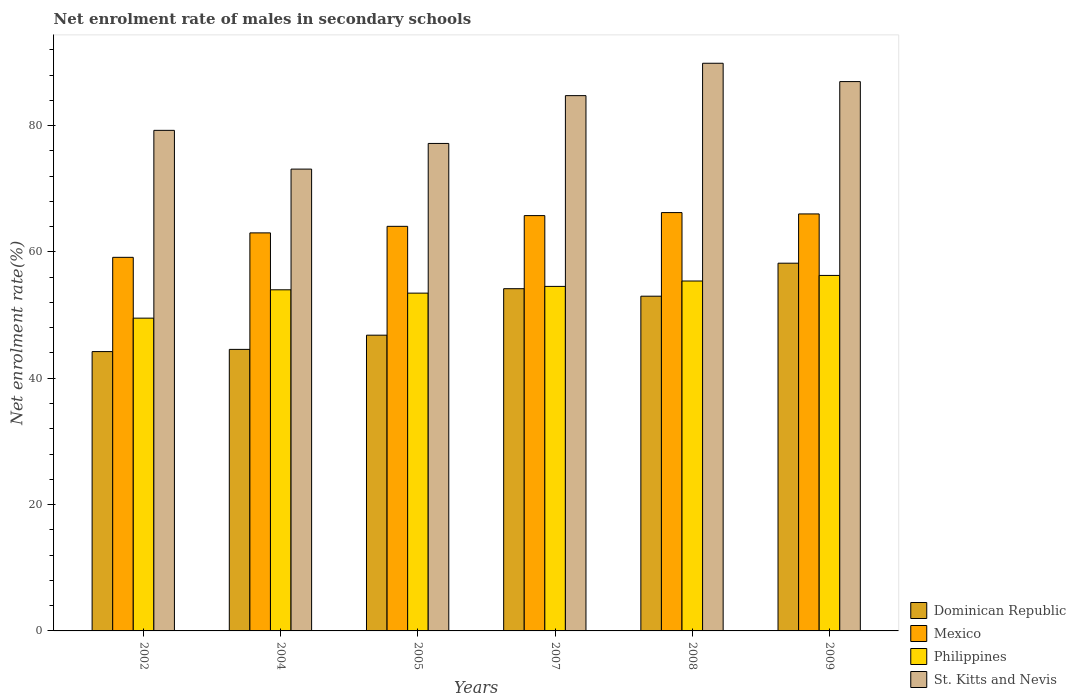How many bars are there on the 2nd tick from the left?
Your answer should be very brief. 4. How many bars are there on the 5th tick from the right?
Ensure brevity in your answer.  4. What is the net enrolment rate of males in secondary schools in St. Kitts and Nevis in 2008?
Your response must be concise. 89.87. Across all years, what is the maximum net enrolment rate of males in secondary schools in St. Kitts and Nevis?
Provide a short and direct response. 89.87. Across all years, what is the minimum net enrolment rate of males in secondary schools in Dominican Republic?
Provide a short and direct response. 44.22. In which year was the net enrolment rate of males in secondary schools in Dominican Republic minimum?
Keep it short and to the point. 2002. What is the total net enrolment rate of males in secondary schools in St. Kitts and Nevis in the graph?
Provide a short and direct response. 491.13. What is the difference between the net enrolment rate of males in secondary schools in Dominican Republic in 2004 and that in 2008?
Provide a short and direct response. -8.42. What is the difference between the net enrolment rate of males in secondary schools in St. Kitts and Nevis in 2008 and the net enrolment rate of males in secondary schools in Mexico in 2005?
Offer a very short reply. 25.82. What is the average net enrolment rate of males in secondary schools in St. Kitts and Nevis per year?
Provide a succinct answer. 81.85. In the year 2005, what is the difference between the net enrolment rate of males in secondary schools in Philippines and net enrolment rate of males in secondary schools in Dominican Republic?
Make the answer very short. 6.66. What is the ratio of the net enrolment rate of males in secondary schools in Dominican Republic in 2005 to that in 2008?
Provide a short and direct response. 0.88. What is the difference between the highest and the second highest net enrolment rate of males in secondary schools in Dominican Republic?
Ensure brevity in your answer.  4.04. What is the difference between the highest and the lowest net enrolment rate of males in secondary schools in Mexico?
Your response must be concise. 7.08. In how many years, is the net enrolment rate of males in secondary schools in Philippines greater than the average net enrolment rate of males in secondary schools in Philippines taken over all years?
Your answer should be very brief. 4. Is the sum of the net enrolment rate of males in secondary schools in Philippines in 2008 and 2009 greater than the maximum net enrolment rate of males in secondary schools in Dominican Republic across all years?
Your answer should be very brief. Yes. Is it the case that in every year, the sum of the net enrolment rate of males in secondary schools in St. Kitts and Nevis and net enrolment rate of males in secondary schools in Mexico is greater than the net enrolment rate of males in secondary schools in Philippines?
Provide a short and direct response. Yes. How many years are there in the graph?
Provide a succinct answer. 6. What is the difference between two consecutive major ticks on the Y-axis?
Ensure brevity in your answer.  20. Are the values on the major ticks of Y-axis written in scientific E-notation?
Offer a very short reply. No. Does the graph contain any zero values?
Give a very brief answer. No. Does the graph contain grids?
Give a very brief answer. No. How many legend labels are there?
Offer a very short reply. 4. What is the title of the graph?
Provide a short and direct response. Net enrolment rate of males in secondary schools. Does "Grenada" appear as one of the legend labels in the graph?
Provide a succinct answer. No. What is the label or title of the X-axis?
Offer a very short reply. Years. What is the label or title of the Y-axis?
Offer a very short reply. Net enrolment rate(%). What is the Net enrolment rate(%) in Dominican Republic in 2002?
Your response must be concise. 44.22. What is the Net enrolment rate(%) in Mexico in 2002?
Keep it short and to the point. 59.15. What is the Net enrolment rate(%) in Philippines in 2002?
Offer a very short reply. 49.52. What is the Net enrolment rate(%) in St. Kitts and Nevis in 2002?
Ensure brevity in your answer.  79.25. What is the Net enrolment rate(%) in Dominican Republic in 2004?
Keep it short and to the point. 44.57. What is the Net enrolment rate(%) in Mexico in 2004?
Your response must be concise. 63.02. What is the Net enrolment rate(%) in Philippines in 2004?
Offer a very short reply. 54.01. What is the Net enrolment rate(%) of St. Kitts and Nevis in 2004?
Make the answer very short. 73.11. What is the Net enrolment rate(%) of Dominican Republic in 2005?
Give a very brief answer. 46.82. What is the Net enrolment rate(%) of Mexico in 2005?
Keep it short and to the point. 64.05. What is the Net enrolment rate(%) of Philippines in 2005?
Provide a short and direct response. 53.48. What is the Net enrolment rate(%) of St. Kitts and Nevis in 2005?
Make the answer very short. 77.18. What is the Net enrolment rate(%) in Dominican Republic in 2007?
Provide a succinct answer. 54.18. What is the Net enrolment rate(%) in Mexico in 2007?
Give a very brief answer. 65.75. What is the Net enrolment rate(%) of Philippines in 2007?
Keep it short and to the point. 54.54. What is the Net enrolment rate(%) of St. Kitts and Nevis in 2007?
Your answer should be compact. 84.75. What is the Net enrolment rate(%) in Dominican Republic in 2008?
Offer a very short reply. 52.99. What is the Net enrolment rate(%) in Mexico in 2008?
Ensure brevity in your answer.  66.23. What is the Net enrolment rate(%) of Philippines in 2008?
Provide a short and direct response. 55.4. What is the Net enrolment rate(%) of St. Kitts and Nevis in 2008?
Provide a short and direct response. 89.87. What is the Net enrolment rate(%) in Dominican Republic in 2009?
Give a very brief answer. 58.22. What is the Net enrolment rate(%) in Mexico in 2009?
Your answer should be compact. 66.02. What is the Net enrolment rate(%) in Philippines in 2009?
Make the answer very short. 56.28. What is the Net enrolment rate(%) in St. Kitts and Nevis in 2009?
Give a very brief answer. 86.97. Across all years, what is the maximum Net enrolment rate(%) of Dominican Republic?
Provide a succinct answer. 58.22. Across all years, what is the maximum Net enrolment rate(%) of Mexico?
Make the answer very short. 66.23. Across all years, what is the maximum Net enrolment rate(%) of Philippines?
Make the answer very short. 56.28. Across all years, what is the maximum Net enrolment rate(%) of St. Kitts and Nevis?
Give a very brief answer. 89.87. Across all years, what is the minimum Net enrolment rate(%) of Dominican Republic?
Offer a very short reply. 44.22. Across all years, what is the minimum Net enrolment rate(%) in Mexico?
Offer a terse response. 59.15. Across all years, what is the minimum Net enrolment rate(%) of Philippines?
Your answer should be very brief. 49.52. Across all years, what is the minimum Net enrolment rate(%) of St. Kitts and Nevis?
Your answer should be compact. 73.11. What is the total Net enrolment rate(%) of Dominican Republic in the graph?
Offer a very short reply. 301.01. What is the total Net enrolment rate(%) in Mexico in the graph?
Provide a short and direct response. 384.22. What is the total Net enrolment rate(%) of Philippines in the graph?
Ensure brevity in your answer.  323.23. What is the total Net enrolment rate(%) of St. Kitts and Nevis in the graph?
Provide a short and direct response. 491.13. What is the difference between the Net enrolment rate(%) in Dominican Republic in 2002 and that in 2004?
Offer a very short reply. -0.35. What is the difference between the Net enrolment rate(%) in Mexico in 2002 and that in 2004?
Your response must be concise. -3.87. What is the difference between the Net enrolment rate(%) in Philippines in 2002 and that in 2004?
Keep it short and to the point. -4.49. What is the difference between the Net enrolment rate(%) in St. Kitts and Nevis in 2002 and that in 2004?
Keep it short and to the point. 6.14. What is the difference between the Net enrolment rate(%) in Dominican Republic in 2002 and that in 2005?
Your answer should be compact. -2.6. What is the difference between the Net enrolment rate(%) in Mexico in 2002 and that in 2005?
Ensure brevity in your answer.  -4.91. What is the difference between the Net enrolment rate(%) in Philippines in 2002 and that in 2005?
Ensure brevity in your answer.  -3.96. What is the difference between the Net enrolment rate(%) in St. Kitts and Nevis in 2002 and that in 2005?
Give a very brief answer. 2.07. What is the difference between the Net enrolment rate(%) of Dominican Republic in 2002 and that in 2007?
Ensure brevity in your answer.  -9.96. What is the difference between the Net enrolment rate(%) in Mexico in 2002 and that in 2007?
Make the answer very short. -6.61. What is the difference between the Net enrolment rate(%) in Philippines in 2002 and that in 2007?
Your answer should be very brief. -5.03. What is the difference between the Net enrolment rate(%) of St. Kitts and Nevis in 2002 and that in 2007?
Offer a terse response. -5.5. What is the difference between the Net enrolment rate(%) in Dominican Republic in 2002 and that in 2008?
Your answer should be very brief. -8.77. What is the difference between the Net enrolment rate(%) in Mexico in 2002 and that in 2008?
Your answer should be very brief. -7.08. What is the difference between the Net enrolment rate(%) of Philippines in 2002 and that in 2008?
Offer a very short reply. -5.88. What is the difference between the Net enrolment rate(%) of St. Kitts and Nevis in 2002 and that in 2008?
Keep it short and to the point. -10.62. What is the difference between the Net enrolment rate(%) in Dominican Republic in 2002 and that in 2009?
Ensure brevity in your answer.  -13.99. What is the difference between the Net enrolment rate(%) of Mexico in 2002 and that in 2009?
Provide a short and direct response. -6.87. What is the difference between the Net enrolment rate(%) of Philippines in 2002 and that in 2009?
Ensure brevity in your answer.  -6.77. What is the difference between the Net enrolment rate(%) of St. Kitts and Nevis in 2002 and that in 2009?
Your response must be concise. -7.72. What is the difference between the Net enrolment rate(%) in Dominican Republic in 2004 and that in 2005?
Give a very brief answer. -2.25. What is the difference between the Net enrolment rate(%) of Mexico in 2004 and that in 2005?
Make the answer very short. -1.04. What is the difference between the Net enrolment rate(%) of Philippines in 2004 and that in 2005?
Provide a succinct answer. 0.53. What is the difference between the Net enrolment rate(%) of St. Kitts and Nevis in 2004 and that in 2005?
Provide a succinct answer. -4.06. What is the difference between the Net enrolment rate(%) in Dominican Republic in 2004 and that in 2007?
Ensure brevity in your answer.  -9.61. What is the difference between the Net enrolment rate(%) in Mexico in 2004 and that in 2007?
Give a very brief answer. -2.74. What is the difference between the Net enrolment rate(%) of Philippines in 2004 and that in 2007?
Offer a terse response. -0.54. What is the difference between the Net enrolment rate(%) in St. Kitts and Nevis in 2004 and that in 2007?
Give a very brief answer. -11.63. What is the difference between the Net enrolment rate(%) of Dominican Republic in 2004 and that in 2008?
Your answer should be very brief. -8.42. What is the difference between the Net enrolment rate(%) in Mexico in 2004 and that in 2008?
Make the answer very short. -3.21. What is the difference between the Net enrolment rate(%) of Philippines in 2004 and that in 2008?
Your answer should be very brief. -1.39. What is the difference between the Net enrolment rate(%) of St. Kitts and Nevis in 2004 and that in 2008?
Provide a succinct answer. -16.76. What is the difference between the Net enrolment rate(%) in Dominican Republic in 2004 and that in 2009?
Offer a very short reply. -13.64. What is the difference between the Net enrolment rate(%) in Mexico in 2004 and that in 2009?
Your answer should be very brief. -3. What is the difference between the Net enrolment rate(%) of Philippines in 2004 and that in 2009?
Give a very brief answer. -2.28. What is the difference between the Net enrolment rate(%) of St. Kitts and Nevis in 2004 and that in 2009?
Your response must be concise. -13.85. What is the difference between the Net enrolment rate(%) of Dominican Republic in 2005 and that in 2007?
Your answer should be very brief. -7.36. What is the difference between the Net enrolment rate(%) in Mexico in 2005 and that in 2007?
Provide a short and direct response. -1.7. What is the difference between the Net enrolment rate(%) of Philippines in 2005 and that in 2007?
Your answer should be very brief. -1.06. What is the difference between the Net enrolment rate(%) in St. Kitts and Nevis in 2005 and that in 2007?
Ensure brevity in your answer.  -7.57. What is the difference between the Net enrolment rate(%) in Dominican Republic in 2005 and that in 2008?
Offer a very short reply. -6.17. What is the difference between the Net enrolment rate(%) in Mexico in 2005 and that in 2008?
Provide a succinct answer. -2.18. What is the difference between the Net enrolment rate(%) in Philippines in 2005 and that in 2008?
Ensure brevity in your answer.  -1.92. What is the difference between the Net enrolment rate(%) in St. Kitts and Nevis in 2005 and that in 2008?
Make the answer very short. -12.69. What is the difference between the Net enrolment rate(%) in Dominican Republic in 2005 and that in 2009?
Keep it short and to the point. -11.4. What is the difference between the Net enrolment rate(%) of Mexico in 2005 and that in 2009?
Make the answer very short. -1.96. What is the difference between the Net enrolment rate(%) of Philippines in 2005 and that in 2009?
Ensure brevity in your answer.  -2.8. What is the difference between the Net enrolment rate(%) in St. Kitts and Nevis in 2005 and that in 2009?
Keep it short and to the point. -9.79. What is the difference between the Net enrolment rate(%) in Dominican Republic in 2007 and that in 2008?
Make the answer very short. 1.19. What is the difference between the Net enrolment rate(%) in Mexico in 2007 and that in 2008?
Ensure brevity in your answer.  -0.48. What is the difference between the Net enrolment rate(%) of Philippines in 2007 and that in 2008?
Your answer should be very brief. -0.85. What is the difference between the Net enrolment rate(%) in St. Kitts and Nevis in 2007 and that in 2008?
Your answer should be compact. -5.13. What is the difference between the Net enrolment rate(%) of Dominican Republic in 2007 and that in 2009?
Your response must be concise. -4.04. What is the difference between the Net enrolment rate(%) of Mexico in 2007 and that in 2009?
Give a very brief answer. -0.27. What is the difference between the Net enrolment rate(%) in Philippines in 2007 and that in 2009?
Keep it short and to the point. -1.74. What is the difference between the Net enrolment rate(%) of St. Kitts and Nevis in 2007 and that in 2009?
Ensure brevity in your answer.  -2.22. What is the difference between the Net enrolment rate(%) of Dominican Republic in 2008 and that in 2009?
Ensure brevity in your answer.  -5.22. What is the difference between the Net enrolment rate(%) in Mexico in 2008 and that in 2009?
Offer a very short reply. 0.21. What is the difference between the Net enrolment rate(%) in Philippines in 2008 and that in 2009?
Your response must be concise. -0.88. What is the difference between the Net enrolment rate(%) of St. Kitts and Nevis in 2008 and that in 2009?
Your response must be concise. 2.9. What is the difference between the Net enrolment rate(%) in Dominican Republic in 2002 and the Net enrolment rate(%) in Mexico in 2004?
Keep it short and to the point. -18.79. What is the difference between the Net enrolment rate(%) of Dominican Republic in 2002 and the Net enrolment rate(%) of Philippines in 2004?
Provide a succinct answer. -9.78. What is the difference between the Net enrolment rate(%) in Dominican Republic in 2002 and the Net enrolment rate(%) in St. Kitts and Nevis in 2004?
Give a very brief answer. -28.89. What is the difference between the Net enrolment rate(%) of Mexico in 2002 and the Net enrolment rate(%) of Philippines in 2004?
Your answer should be very brief. 5.14. What is the difference between the Net enrolment rate(%) in Mexico in 2002 and the Net enrolment rate(%) in St. Kitts and Nevis in 2004?
Offer a very short reply. -13.97. What is the difference between the Net enrolment rate(%) of Philippines in 2002 and the Net enrolment rate(%) of St. Kitts and Nevis in 2004?
Offer a terse response. -23.6. What is the difference between the Net enrolment rate(%) of Dominican Republic in 2002 and the Net enrolment rate(%) of Mexico in 2005?
Your response must be concise. -19.83. What is the difference between the Net enrolment rate(%) in Dominican Republic in 2002 and the Net enrolment rate(%) in Philippines in 2005?
Make the answer very short. -9.26. What is the difference between the Net enrolment rate(%) of Dominican Republic in 2002 and the Net enrolment rate(%) of St. Kitts and Nevis in 2005?
Offer a very short reply. -32.95. What is the difference between the Net enrolment rate(%) of Mexico in 2002 and the Net enrolment rate(%) of Philippines in 2005?
Offer a terse response. 5.67. What is the difference between the Net enrolment rate(%) in Mexico in 2002 and the Net enrolment rate(%) in St. Kitts and Nevis in 2005?
Your answer should be compact. -18.03. What is the difference between the Net enrolment rate(%) in Philippines in 2002 and the Net enrolment rate(%) in St. Kitts and Nevis in 2005?
Offer a terse response. -27.66. What is the difference between the Net enrolment rate(%) of Dominican Republic in 2002 and the Net enrolment rate(%) of Mexico in 2007?
Offer a very short reply. -21.53. What is the difference between the Net enrolment rate(%) in Dominican Republic in 2002 and the Net enrolment rate(%) in Philippines in 2007?
Give a very brief answer. -10.32. What is the difference between the Net enrolment rate(%) in Dominican Republic in 2002 and the Net enrolment rate(%) in St. Kitts and Nevis in 2007?
Provide a short and direct response. -40.52. What is the difference between the Net enrolment rate(%) in Mexico in 2002 and the Net enrolment rate(%) in Philippines in 2007?
Offer a very short reply. 4.6. What is the difference between the Net enrolment rate(%) in Mexico in 2002 and the Net enrolment rate(%) in St. Kitts and Nevis in 2007?
Ensure brevity in your answer.  -25.6. What is the difference between the Net enrolment rate(%) in Philippines in 2002 and the Net enrolment rate(%) in St. Kitts and Nevis in 2007?
Your response must be concise. -35.23. What is the difference between the Net enrolment rate(%) of Dominican Republic in 2002 and the Net enrolment rate(%) of Mexico in 2008?
Ensure brevity in your answer.  -22.01. What is the difference between the Net enrolment rate(%) in Dominican Republic in 2002 and the Net enrolment rate(%) in Philippines in 2008?
Give a very brief answer. -11.17. What is the difference between the Net enrolment rate(%) in Dominican Republic in 2002 and the Net enrolment rate(%) in St. Kitts and Nevis in 2008?
Offer a very short reply. -45.65. What is the difference between the Net enrolment rate(%) in Mexico in 2002 and the Net enrolment rate(%) in Philippines in 2008?
Offer a very short reply. 3.75. What is the difference between the Net enrolment rate(%) in Mexico in 2002 and the Net enrolment rate(%) in St. Kitts and Nevis in 2008?
Your answer should be compact. -30.73. What is the difference between the Net enrolment rate(%) of Philippines in 2002 and the Net enrolment rate(%) of St. Kitts and Nevis in 2008?
Keep it short and to the point. -40.35. What is the difference between the Net enrolment rate(%) in Dominican Republic in 2002 and the Net enrolment rate(%) in Mexico in 2009?
Your response must be concise. -21.79. What is the difference between the Net enrolment rate(%) in Dominican Republic in 2002 and the Net enrolment rate(%) in Philippines in 2009?
Offer a very short reply. -12.06. What is the difference between the Net enrolment rate(%) of Dominican Republic in 2002 and the Net enrolment rate(%) of St. Kitts and Nevis in 2009?
Offer a terse response. -42.74. What is the difference between the Net enrolment rate(%) in Mexico in 2002 and the Net enrolment rate(%) in Philippines in 2009?
Keep it short and to the point. 2.86. What is the difference between the Net enrolment rate(%) in Mexico in 2002 and the Net enrolment rate(%) in St. Kitts and Nevis in 2009?
Ensure brevity in your answer.  -27.82. What is the difference between the Net enrolment rate(%) in Philippines in 2002 and the Net enrolment rate(%) in St. Kitts and Nevis in 2009?
Provide a short and direct response. -37.45. What is the difference between the Net enrolment rate(%) of Dominican Republic in 2004 and the Net enrolment rate(%) of Mexico in 2005?
Your answer should be compact. -19.48. What is the difference between the Net enrolment rate(%) of Dominican Republic in 2004 and the Net enrolment rate(%) of Philippines in 2005?
Your response must be concise. -8.91. What is the difference between the Net enrolment rate(%) of Dominican Republic in 2004 and the Net enrolment rate(%) of St. Kitts and Nevis in 2005?
Ensure brevity in your answer.  -32.6. What is the difference between the Net enrolment rate(%) of Mexico in 2004 and the Net enrolment rate(%) of Philippines in 2005?
Offer a very short reply. 9.54. What is the difference between the Net enrolment rate(%) of Mexico in 2004 and the Net enrolment rate(%) of St. Kitts and Nevis in 2005?
Provide a succinct answer. -14.16. What is the difference between the Net enrolment rate(%) of Philippines in 2004 and the Net enrolment rate(%) of St. Kitts and Nevis in 2005?
Offer a very short reply. -23.17. What is the difference between the Net enrolment rate(%) in Dominican Republic in 2004 and the Net enrolment rate(%) in Mexico in 2007?
Give a very brief answer. -21.18. What is the difference between the Net enrolment rate(%) of Dominican Republic in 2004 and the Net enrolment rate(%) of Philippines in 2007?
Provide a short and direct response. -9.97. What is the difference between the Net enrolment rate(%) in Dominican Republic in 2004 and the Net enrolment rate(%) in St. Kitts and Nevis in 2007?
Make the answer very short. -40.17. What is the difference between the Net enrolment rate(%) in Mexico in 2004 and the Net enrolment rate(%) in Philippines in 2007?
Offer a terse response. 8.47. What is the difference between the Net enrolment rate(%) in Mexico in 2004 and the Net enrolment rate(%) in St. Kitts and Nevis in 2007?
Your answer should be compact. -21.73. What is the difference between the Net enrolment rate(%) of Philippines in 2004 and the Net enrolment rate(%) of St. Kitts and Nevis in 2007?
Keep it short and to the point. -30.74. What is the difference between the Net enrolment rate(%) of Dominican Republic in 2004 and the Net enrolment rate(%) of Mexico in 2008?
Provide a succinct answer. -21.66. What is the difference between the Net enrolment rate(%) in Dominican Republic in 2004 and the Net enrolment rate(%) in Philippines in 2008?
Make the answer very short. -10.83. What is the difference between the Net enrolment rate(%) in Dominican Republic in 2004 and the Net enrolment rate(%) in St. Kitts and Nevis in 2008?
Give a very brief answer. -45.3. What is the difference between the Net enrolment rate(%) in Mexico in 2004 and the Net enrolment rate(%) in Philippines in 2008?
Make the answer very short. 7.62. What is the difference between the Net enrolment rate(%) in Mexico in 2004 and the Net enrolment rate(%) in St. Kitts and Nevis in 2008?
Make the answer very short. -26.85. What is the difference between the Net enrolment rate(%) in Philippines in 2004 and the Net enrolment rate(%) in St. Kitts and Nevis in 2008?
Give a very brief answer. -35.87. What is the difference between the Net enrolment rate(%) in Dominican Republic in 2004 and the Net enrolment rate(%) in Mexico in 2009?
Your response must be concise. -21.44. What is the difference between the Net enrolment rate(%) in Dominican Republic in 2004 and the Net enrolment rate(%) in Philippines in 2009?
Keep it short and to the point. -11.71. What is the difference between the Net enrolment rate(%) of Dominican Republic in 2004 and the Net enrolment rate(%) of St. Kitts and Nevis in 2009?
Ensure brevity in your answer.  -42.4. What is the difference between the Net enrolment rate(%) of Mexico in 2004 and the Net enrolment rate(%) of Philippines in 2009?
Keep it short and to the point. 6.73. What is the difference between the Net enrolment rate(%) in Mexico in 2004 and the Net enrolment rate(%) in St. Kitts and Nevis in 2009?
Make the answer very short. -23.95. What is the difference between the Net enrolment rate(%) in Philippines in 2004 and the Net enrolment rate(%) in St. Kitts and Nevis in 2009?
Provide a short and direct response. -32.96. What is the difference between the Net enrolment rate(%) in Dominican Republic in 2005 and the Net enrolment rate(%) in Mexico in 2007?
Give a very brief answer. -18.93. What is the difference between the Net enrolment rate(%) of Dominican Republic in 2005 and the Net enrolment rate(%) of Philippines in 2007?
Your answer should be very brief. -7.72. What is the difference between the Net enrolment rate(%) of Dominican Republic in 2005 and the Net enrolment rate(%) of St. Kitts and Nevis in 2007?
Offer a very short reply. -37.92. What is the difference between the Net enrolment rate(%) in Mexico in 2005 and the Net enrolment rate(%) in Philippines in 2007?
Offer a terse response. 9.51. What is the difference between the Net enrolment rate(%) of Mexico in 2005 and the Net enrolment rate(%) of St. Kitts and Nevis in 2007?
Your answer should be compact. -20.69. What is the difference between the Net enrolment rate(%) of Philippines in 2005 and the Net enrolment rate(%) of St. Kitts and Nevis in 2007?
Ensure brevity in your answer.  -31.27. What is the difference between the Net enrolment rate(%) of Dominican Republic in 2005 and the Net enrolment rate(%) of Mexico in 2008?
Keep it short and to the point. -19.41. What is the difference between the Net enrolment rate(%) of Dominican Republic in 2005 and the Net enrolment rate(%) of Philippines in 2008?
Ensure brevity in your answer.  -8.58. What is the difference between the Net enrolment rate(%) in Dominican Republic in 2005 and the Net enrolment rate(%) in St. Kitts and Nevis in 2008?
Offer a very short reply. -43.05. What is the difference between the Net enrolment rate(%) of Mexico in 2005 and the Net enrolment rate(%) of Philippines in 2008?
Offer a terse response. 8.65. What is the difference between the Net enrolment rate(%) in Mexico in 2005 and the Net enrolment rate(%) in St. Kitts and Nevis in 2008?
Your answer should be very brief. -25.82. What is the difference between the Net enrolment rate(%) of Philippines in 2005 and the Net enrolment rate(%) of St. Kitts and Nevis in 2008?
Give a very brief answer. -36.39. What is the difference between the Net enrolment rate(%) of Dominican Republic in 2005 and the Net enrolment rate(%) of Mexico in 2009?
Make the answer very short. -19.2. What is the difference between the Net enrolment rate(%) of Dominican Republic in 2005 and the Net enrolment rate(%) of Philippines in 2009?
Provide a short and direct response. -9.46. What is the difference between the Net enrolment rate(%) of Dominican Republic in 2005 and the Net enrolment rate(%) of St. Kitts and Nevis in 2009?
Give a very brief answer. -40.15. What is the difference between the Net enrolment rate(%) in Mexico in 2005 and the Net enrolment rate(%) in Philippines in 2009?
Keep it short and to the point. 7.77. What is the difference between the Net enrolment rate(%) of Mexico in 2005 and the Net enrolment rate(%) of St. Kitts and Nevis in 2009?
Your answer should be very brief. -22.92. What is the difference between the Net enrolment rate(%) in Philippines in 2005 and the Net enrolment rate(%) in St. Kitts and Nevis in 2009?
Provide a succinct answer. -33.49. What is the difference between the Net enrolment rate(%) in Dominican Republic in 2007 and the Net enrolment rate(%) in Mexico in 2008?
Your response must be concise. -12.05. What is the difference between the Net enrolment rate(%) of Dominican Republic in 2007 and the Net enrolment rate(%) of Philippines in 2008?
Provide a succinct answer. -1.22. What is the difference between the Net enrolment rate(%) of Dominican Republic in 2007 and the Net enrolment rate(%) of St. Kitts and Nevis in 2008?
Ensure brevity in your answer.  -35.69. What is the difference between the Net enrolment rate(%) in Mexico in 2007 and the Net enrolment rate(%) in Philippines in 2008?
Your response must be concise. 10.35. What is the difference between the Net enrolment rate(%) of Mexico in 2007 and the Net enrolment rate(%) of St. Kitts and Nevis in 2008?
Provide a succinct answer. -24.12. What is the difference between the Net enrolment rate(%) in Philippines in 2007 and the Net enrolment rate(%) in St. Kitts and Nevis in 2008?
Your answer should be very brief. -35.33. What is the difference between the Net enrolment rate(%) of Dominican Republic in 2007 and the Net enrolment rate(%) of Mexico in 2009?
Your response must be concise. -11.84. What is the difference between the Net enrolment rate(%) in Dominican Republic in 2007 and the Net enrolment rate(%) in Philippines in 2009?
Provide a succinct answer. -2.1. What is the difference between the Net enrolment rate(%) of Dominican Republic in 2007 and the Net enrolment rate(%) of St. Kitts and Nevis in 2009?
Keep it short and to the point. -32.79. What is the difference between the Net enrolment rate(%) in Mexico in 2007 and the Net enrolment rate(%) in Philippines in 2009?
Offer a very short reply. 9.47. What is the difference between the Net enrolment rate(%) in Mexico in 2007 and the Net enrolment rate(%) in St. Kitts and Nevis in 2009?
Provide a succinct answer. -21.22. What is the difference between the Net enrolment rate(%) in Philippines in 2007 and the Net enrolment rate(%) in St. Kitts and Nevis in 2009?
Make the answer very short. -32.42. What is the difference between the Net enrolment rate(%) of Dominican Republic in 2008 and the Net enrolment rate(%) of Mexico in 2009?
Give a very brief answer. -13.02. What is the difference between the Net enrolment rate(%) of Dominican Republic in 2008 and the Net enrolment rate(%) of Philippines in 2009?
Your answer should be compact. -3.29. What is the difference between the Net enrolment rate(%) in Dominican Republic in 2008 and the Net enrolment rate(%) in St. Kitts and Nevis in 2009?
Offer a terse response. -33.98. What is the difference between the Net enrolment rate(%) of Mexico in 2008 and the Net enrolment rate(%) of Philippines in 2009?
Provide a succinct answer. 9.95. What is the difference between the Net enrolment rate(%) of Mexico in 2008 and the Net enrolment rate(%) of St. Kitts and Nevis in 2009?
Ensure brevity in your answer.  -20.74. What is the difference between the Net enrolment rate(%) of Philippines in 2008 and the Net enrolment rate(%) of St. Kitts and Nevis in 2009?
Provide a short and direct response. -31.57. What is the average Net enrolment rate(%) in Dominican Republic per year?
Offer a terse response. 50.17. What is the average Net enrolment rate(%) in Mexico per year?
Offer a terse response. 64.04. What is the average Net enrolment rate(%) of Philippines per year?
Your response must be concise. 53.87. What is the average Net enrolment rate(%) of St. Kitts and Nevis per year?
Your answer should be compact. 81.85. In the year 2002, what is the difference between the Net enrolment rate(%) in Dominican Republic and Net enrolment rate(%) in Mexico?
Keep it short and to the point. -14.92. In the year 2002, what is the difference between the Net enrolment rate(%) of Dominican Republic and Net enrolment rate(%) of Philippines?
Keep it short and to the point. -5.29. In the year 2002, what is the difference between the Net enrolment rate(%) in Dominican Republic and Net enrolment rate(%) in St. Kitts and Nevis?
Ensure brevity in your answer.  -35.03. In the year 2002, what is the difference between the Net enrolment rate(%) of Mexico and Net enrolment rate(%) of Philippines?
Provide a succinct answer. 9.63. In the year 2002, what is the difference between the Net enrolment rate(%) of Mexico and Net enrolment rate(%) of St. Kitts and Nevis?
Your answer should be very brief. -20.1. In the year 2002, what is the difference between the Net enrolment rate(%) in Philippines and Net enrolment rate(%) in St. Kitts and Nevis?
Your response must be concise. -29.73. In the year 2004, what is the difference between the Net enrolment rate(%) in Dominican Republic and Net enrolment rate(%) in Mexico?
Make the answer very short. -18.44. In the year 2004, what is the difference between the Net enrolment rate(%) of Dominican Republic and Net enrolment rate(%) of Philippines?
Your answer should be very brief. -9.43. In the year 2004, what is the difference between the Net enrolment rate(%) in Dominican Republic and Net enrolment rate(%) in St. Kitts and Nevis?
Ensure brevity in your answer.  -28.54. In the year 2004, what is the difference between the Net enrolment rate(%) in Mexico and Net enrolment rate(%) in Philippines?
Your answer should be very brief. 9.01. In the year 2004, what is the difference between the Net enrolment rate(%) in Mexico and Net enrolment rate(%) in St. Kitts and Nevis?
Ensure brevity in your answer.  -10.1. In the year 2004, what is the difference between the Net enrolment rate(%) in Philippines and Net enrolment rate(%) in St. Kitts and Nevis?
Make the answer very short. -19.11. In the year 2005, what is the difference between the Net enrolment rate(%) of Dominican Republic and Net enrolment rate(%) of Mexico?
Offer a very short reply. -17.23. In the year 2005, what is the difference between the Net enrolment rate(%) in Dominican Republic and Net enrolment rate(%) in Philippines?
Your response must be concise. -6.66. In the year 2005, what is the difference between the Net enrolment rate(%) of Dominican Republic and Net enrolment rate(%) of St. Kitts and Nevis?
Ensure brevity in your answer.  -30.35. In the year 2005, what is the difference between the Net enrolment rate(%) in Mexico and Net enrolment rate(%) in Philippines?
Give a very brief answer. 10.57. In the year 2005, what is the difference between the Net enrolment rate(%) of Mexico and Net enrolment rate(%) of St. Kitts and Nevis?
Your answer should be very brief. -13.12. In the year 2005, what is the difference between the Net enrolment rate(%) in Philippines and Net enrolment rate(%) in St. Kitts and Nevis?
Offer a terse response. -23.7. In the year 2007, what is the difference between the Net enrolment rate(%) of Dominican Republic and Net enrolment rate(%) of Mexico?
Ensure brevity in your answer.  -11.57. In the year 2007, what is the difference between the Net enrolment rate(%) in Dominican Republic and Net enrolment rate(%) in Philippines?
Keep it short and to the point. -0.36. In the year 2007, what is the difference between the Net enrolment rate(%) in Dominican Republic and Net enrolment rate(%) in St. Kitts and Nevis?
Your answer should be compact. -30.57. In the year 2007, what is the difference between the Net enrolment rate(%) of Mexico and Net enrolment rate(%) of Philippines?
Provide a succinct answer. 11.21. In the year 2007, what is the difference between the Net enrolment rate(%) in Mexico and Net enrolment rate(%) in St. Kitts and Nevis?
Offer a very short reply. -18.99. In the year 2007, what is the difference between the Net enrolment rate(%) in Philippines and Net enrolment rate(%) in St. Kitts and Nevis?
Your answer should be very brief. -30.2. In the year 2008, what is the difference between the Net enrolment rate(%) in Dominican Republic and Net enrolment rate(%) in Mexico?
Provide a short and direct response. -13.24. In the year 2008, what is the difference between the Net enrolment rate(%) in Dominican Republic and Net enrolment rate(%) in Philippines?
Your response must be concise. -2.4. In the year 2008, what is the difference between the Net enrolment rate(%) in Dominican Republic and Net enrolment rate(%) in St. Kitts and Nevis?
Your answer should be compact. -36.88. In the year 2008, what is the difference between the Net enrolment rate(%) in Mexico and Net enrolment rate(%) in Philippines?
Your response must be concise. 10.83. In the year 2008, what is the difference between the Net enrolment rate(%) in Mexico and Net enrolment rate(%) in St. Kitts and Nevis?
Your answer should be very brief. -23.64. In the year 2008, what is the difference between the Net enrolment rate(%) in Philippines and Net enrolment rate(%) in St. Kitts and Nevis?
Give a very brief answer. -34.47. In the year 2009, what is the difference between the Net enrolment rate(%) of Dominican Republic and Net enrolment rate(%) of Mexico?
Give a very brief answer. -7.8. In the year 2009, what is the difference between the Net enrolment rate(%) in Dominican Republic and Net enrolment rate(%) in Philippines?
Your answer should be compact. 1.94. In the year 2009, what is the difference between the Net enrolment rate(%) of Dominican Republic and Net enrolment rate(%) of St. Kitts and Nevis?
Offer a terse response. -28.75. In the year 2009, what is the difference between the Net enrolment rate(%) in Mexico and Net enrolment rate(%) in Philippines?
Keep it short and to the point. 9.74. In the year 2009, what is the difference between the Net enrolment rate(%) in Mexico and Net enrolment rate(%) in St. Kitts and Nevis?
Provide a short and direct response. -20.95. In the year 2009, what is the difference between the Net enrolment rate(%) of Philippines and Net enrolment rate(%) of St. Kitts and Nevis?
Make the answer very short. -30.69. What is the ratio of the Net enrolment rate(%) of Mexico in 2002 to that in 2004?
Provide a succinct answer. 0.94. What is the ratio of the Net enrolment rate(%) in Philippines in 2002 to that in 2004?
Make the answer very short. 0.92. What is the ratio of the Net enrolment rate(%) in St. Kitts and Nevis in 2002 to that in 2004?
Offer a very short reply. 1.08. What is the ratio of the Net enrolment rate(%) of Dominican Republic in 2002 to that in 2005?
Give a very brief answer. 0.94. What is the ratio of the Net enrolment rate(%) in Mexico in 2002 to that in 2005?
Ensure brevity in your answer.  0.92. What is the ratio of the Net enrolment rate(%) in Philippines in 2002 to that in 2005?
Give a very brief answer. 0.93. What is the ratio of the Net enrolment rate(%) of St. Kitts and Nevis in 2002 to that in 2005?
Your response must be concise. 1.03. What is the ratio of the Net enrolment rate(%) in Dominican Republic in 2002 to that in 2007?
Offer a terse response. 0.82. What is the ratio of the Net enrolment rate(%) of Mexico in 2002 to that in 2007?
Offer a very short reply. 0.9. What is the ratio of the Net enrolment rate(%) of Philippines in 2002 to that in 2007?
Provide a short and direct response. 0.91. What is the ratio of the Net enrolment rate(%) in St. Kitts and Nevis in 2002 to that in 2007?
Keep it short and to the point. 0.94. What is the ratio of the Net enrolment rate(%) in Dominican Republic in 2002 to that in 2008?
Ensure brevity in your answer.  0.83. What is the ratio of the Net enrolment rate(%) of Mexico in 2002 to that in 2008?
Give a very brief answer. 0.89. What is the ratio of the Net enrolment rate(%) of Philippines in 2002 to that in 2008?
Make the answer very short. 0.89. What is the ratio of the Net enrolment rate(%) in St. Kitts and Nevis in 2002 to that in 2008?
Your response must be concise. 0.88. What is the ratio of the Net enrolment rate(%) of Dominican Republic in 2002 to that in 2009?
Offer a terse response. 0.76. What is the ratio of the Net enrolment rate(%) in Mexico in 2002 to that in 2009?
Ensure brevity in your answer.  0.9. What is the ratio of the Net enrolment rate(%) in Philippines in 2002 to that in 2009?
Offer a very short reply. 0.88. What is the ratio of the Net enrolment rate(%) in St. Kitts and Nevis in 2002 to that in 2009?
Give a very brief answer. 0.91. What is the ratio of the Net enrolment rate(%) in Mexico in 2004 to that in 2005?
Provide a short and direct response. 0.98. What is the ratio of the Net enrolment rate(%) in Philippines in 2004 to that in 2005?
Your response must be concise. 1.01. What is the ratio of the Net enrolment rate(%) of St. Kitts and Nevis in 2004 to that in 2005?
Your answer should be compact. 0.95. What is the ratio of the Net enrolment rate(%) of Dominican Republic in 2004 to that in 2007?
Provide a succinct answer. 0.82. What is the ratio of the Net enrolment rate(%) of Mexico in 2004 to that in 2007?
Provide a short and direct response. 0.96. What is the ratio of the Net enrolment rate(%) of Philippines in 2004 to that in 2007?
Ensure brevity in your answer.  0.99. What is the ratio of the Net enrolment rate(%) of St. Kitts and Nevis in 2004 to that in 2007?
Give a very brief answer. 0.86. What is the ratio of the Net enrolment rate(%) in Dominican Republic in 2004 to that in 2008?
Keep it short and to the point. 0.84. What is the ratio of the Net enrolment rate(%) of Mexico in 2004 to that in 2008?
Your response must be concise. 0.95. What is the ratio of the Net enrolment rate(%) of Philippines in 2004 to that in 2008?
Provide a short and direct response. 0.97. What is the ratio of the Net enrolment rate(%) in St. Kitts and Nevis in 2004 to that in 2008?
Offer a very short reply. 0.81. What is the ratio of the Net enrolment rate(%) in Dominican Republic in 2004 to that in 2009?
Your response must be concise. 0.77. What is the ratio of the Net enrolment rate(%) in Mexico in 2004 to that in 2009?
Ensure brevity in your answer.  0.95. What is the ratio of the Net enrolment rate(%) in Philippines in 2004 to that in 2009?
Your response must be concise. 0.96. What is the ratio of the Net enrolment rate(%) of St. Kitts and Nevis in 2004 to that in 2009?
Give a very brief answer. 0.84. What is the ratio of the Net enrolment rate(%) of Dominican Republic in 2005 to that in 2007?
Give a very brief answer. 0.86. What is the ratio of the Net enrolment rate(%) of Mexico in 2005 to that in 2007?
Ensure brevity in your answer.  0.97. What is the ratio of the Net enrolment rate(%) in Philippines in 2005 to that in 2007?
Ensure brevity in your answer.  0.98. What is the ratio of the Net enrolment rate(%) in St. Kitts and Nevis in 2005 to that in 2007?
Make the answer very short. 0.91. What is the ratio of the Net enrolment rate(%) of Dominican Republic in 2005 to that in 2008?
Your response must be concise. 0.88. What is the ratio of the Net enrolment rate(%) in Mexico in 2005 to that in 2008?
Your response must be concise. 0.97. What is the ratio of the Net enrolment rate(%) in Philippines in 2005 to that in 2008?
Offer a terse response. 0.97. What is the ratio of the Net enrolment rate(%) of St. Kitts and Nevis in 2005 to that in 2008?
Your answer should be very brief. 0.86. What is the ratio of the Net enrolment rate(%) of Dominican Republic in 2005 to that in 2009?
Your answer should be compact. 0.8. What is the ratio of the Net enrolment rate(%) in Mexico in 2005 to that in 2009?
Your answer should be very brief. 0.97. What is the ratio of the Net enrolment rate(%) of Philippines in 2005 to that in 2009?
Give a very brief answer. 0.95. What is the ratio of the Net enrolment rate(%) of St. Kitts and Nevis in 2005 to that in 2009?
Ensure brevity in your answer.  0.89. What is the ratio of the Net enrolment rate(%) of Dominican Republic in 2007 to that in 2008?
Keep it short and to the point. 1.02. What is the ratio of the Net enrolment rate(%) of Philippines in 2007 to that in 2008?
Ensure brevity in your answer.  0.98. What is the ratio of the Net enrolment rate(%) of St. Kitts and Nevis in 2007 to that in 2008?
Offer a terse response. 0.94. What is the ratio of the Net enrolment rate(%) in Dominican Republic in 2007 to that in 2009?
Give a very brief answer. 0.93. What is the ratio of the Net enrolment rate(%) in Philippines in 2007 to that in 2009?
Provide a short and direct response. 0.97. What is the ratio of the Net enrolment rate(%) of St. Kitts and Nevis in 2007 to that in 2009?
Ensure brevity in your answer.  0.97. What is the ratio of the Net enrolment rate(%) of Dominican Republic in 2008 to that in 2009?
Provide a succinct answer. 0.91. What is the ratio of the Net enrolment rate(%) in Mexico in 2008 to that in 2009?
Offer a very short reply. 1. What is the ratio of the Net enrolment rate(%) of Philippines in 2008 to that in 2009?
Ensure brevity in your answer.  0.98. What is the ratio of the Net enrolment rate(%) in St. Kitts and Nevis in 2008 to that in 2009?
Your answer should be compact. 1.03. What is the difference between the highest and the second highest Net enrolment rate(%) of Dominican Republic?
Your answer should be very brief. 4.04. What is the difference between the highest and the second highest Net enrolment rate(%) in Mexico?
Provide a short and direct response. 0.21. What is the difference between the highest and the second highest Net enrolment rate(%) of Philippines?
Your answer should be compact. 0.88. What is the difference between the highest and the second highest Net enrolment rate(%) in St. Kitts and Nevis?
Provide a short and direct response. 2.9. What is the difference between the highest and the lowest Net enrolment rate(%) of Dominican Republic?
Provide a short and direct response. 13.99. What is the difference between the highest and the lowest Net enrolment rate(%) of Mexico?
Ensure brevity in your answer.  7.08. What is the difference between the highest and the lowest Net enrolment rate(%) of Philippines?
Give a very brief answer. 6.77. What is the difference between the highest and the lowest Net enrolment rate(%) of St. Kitts and Nevis?
Make the answer very short. 16.76. 